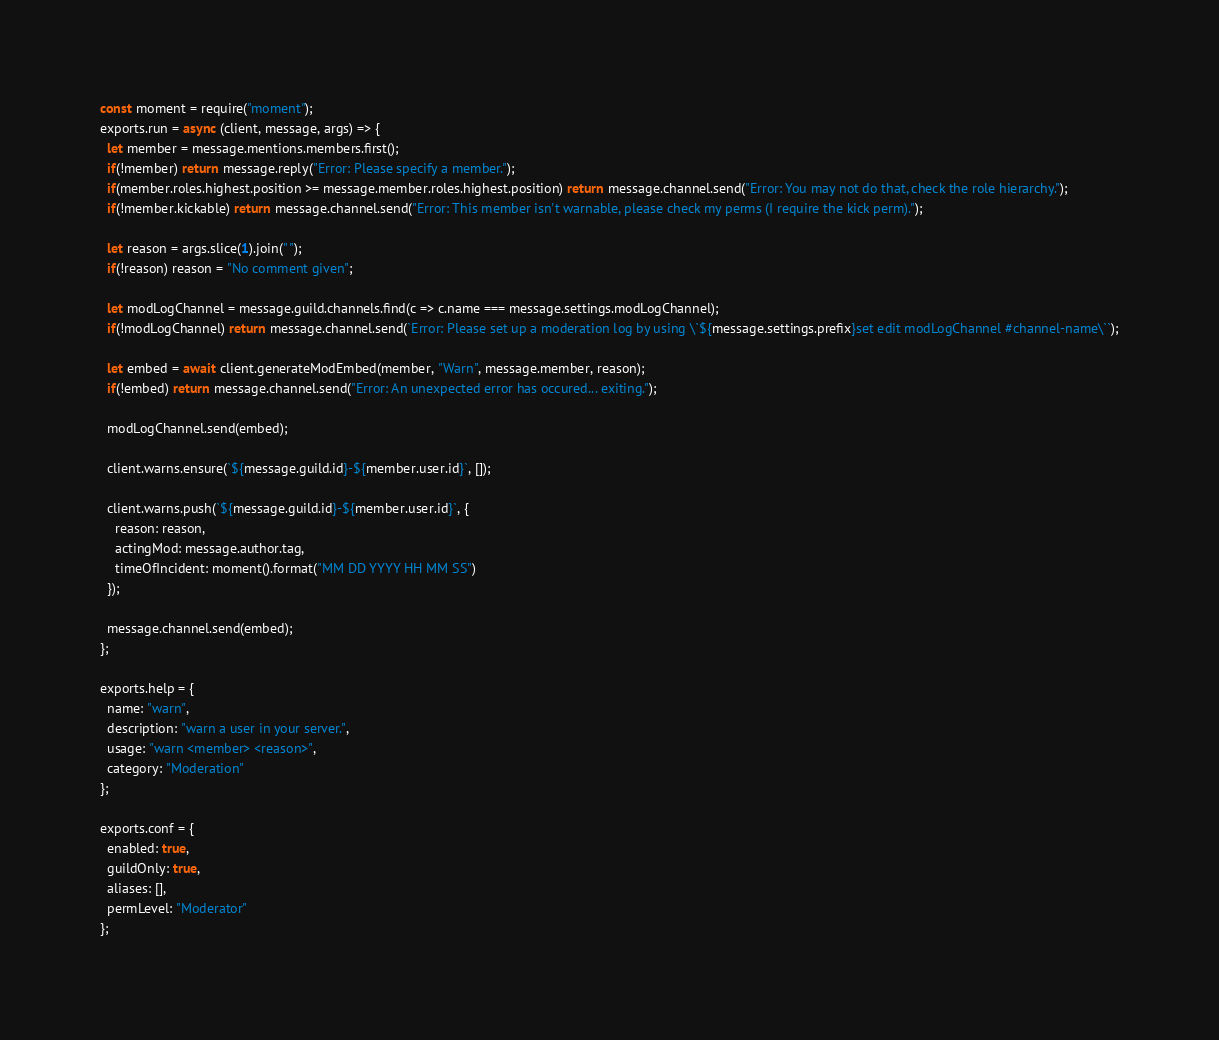Convert code to text. <code><loc_0><loc_0><loc_500><loc_500><_JavaScript_>const moment = require("moment");
exports.run = async (client, message, args) => {
  let member = message.mentions.members.first();
  if(!member) return message.reply("Error: Please specify a member.");
  if(member.roles.highest.position >= message.member.roles.highest.position) return message.channel.send("Error: You may not do that, check the role hierarchy.");
  if(!member.kickable) return message.channel.send("Error: This member isn't warnable, please check my perms (I require the kick perm).");

  let reason = args.slice(1).join(" ");
  if(!reason) reason = "No comment given";

  let modLogChannel = message.guild.channels.find(c => c.name === message.settings.modLogChannel);
  if(!modLogChannel) return message.channel.send(`Error: Please set up a moderation log by using \`${message.settings.prefix}set edit modLogChannel #channel-name\``);

  let embed = await client.generateModEmbed(member, "Warn", message.member, reason);
  if(!embed) return message.channel.send("Error: An unexpected error has occured... exiting.");

  modLogChannel.send(embed);
  
  client.warns.ensure(`${message.guild.id}-${member.user.id}`, []);

  client.warns.push(`${message.guild.id}-${member.user.id}`, {
    reason: reason,
    actingMod: message.author.tag,
    timeOfIncident: moment().format("MM DD YYYY HH MM SS") 
  });

  message.channel.send(embed);
};

exports.help = {
  name: "warn",
  description: "warn a user in your server.",
  usage: "warn <member> <reason>",
  category: "Moderation"
};

exports.conf = {
  enabled: true,
  guildOnly: true,
  aliases: [],
  permLevel: "Moderator"
};
</code> 